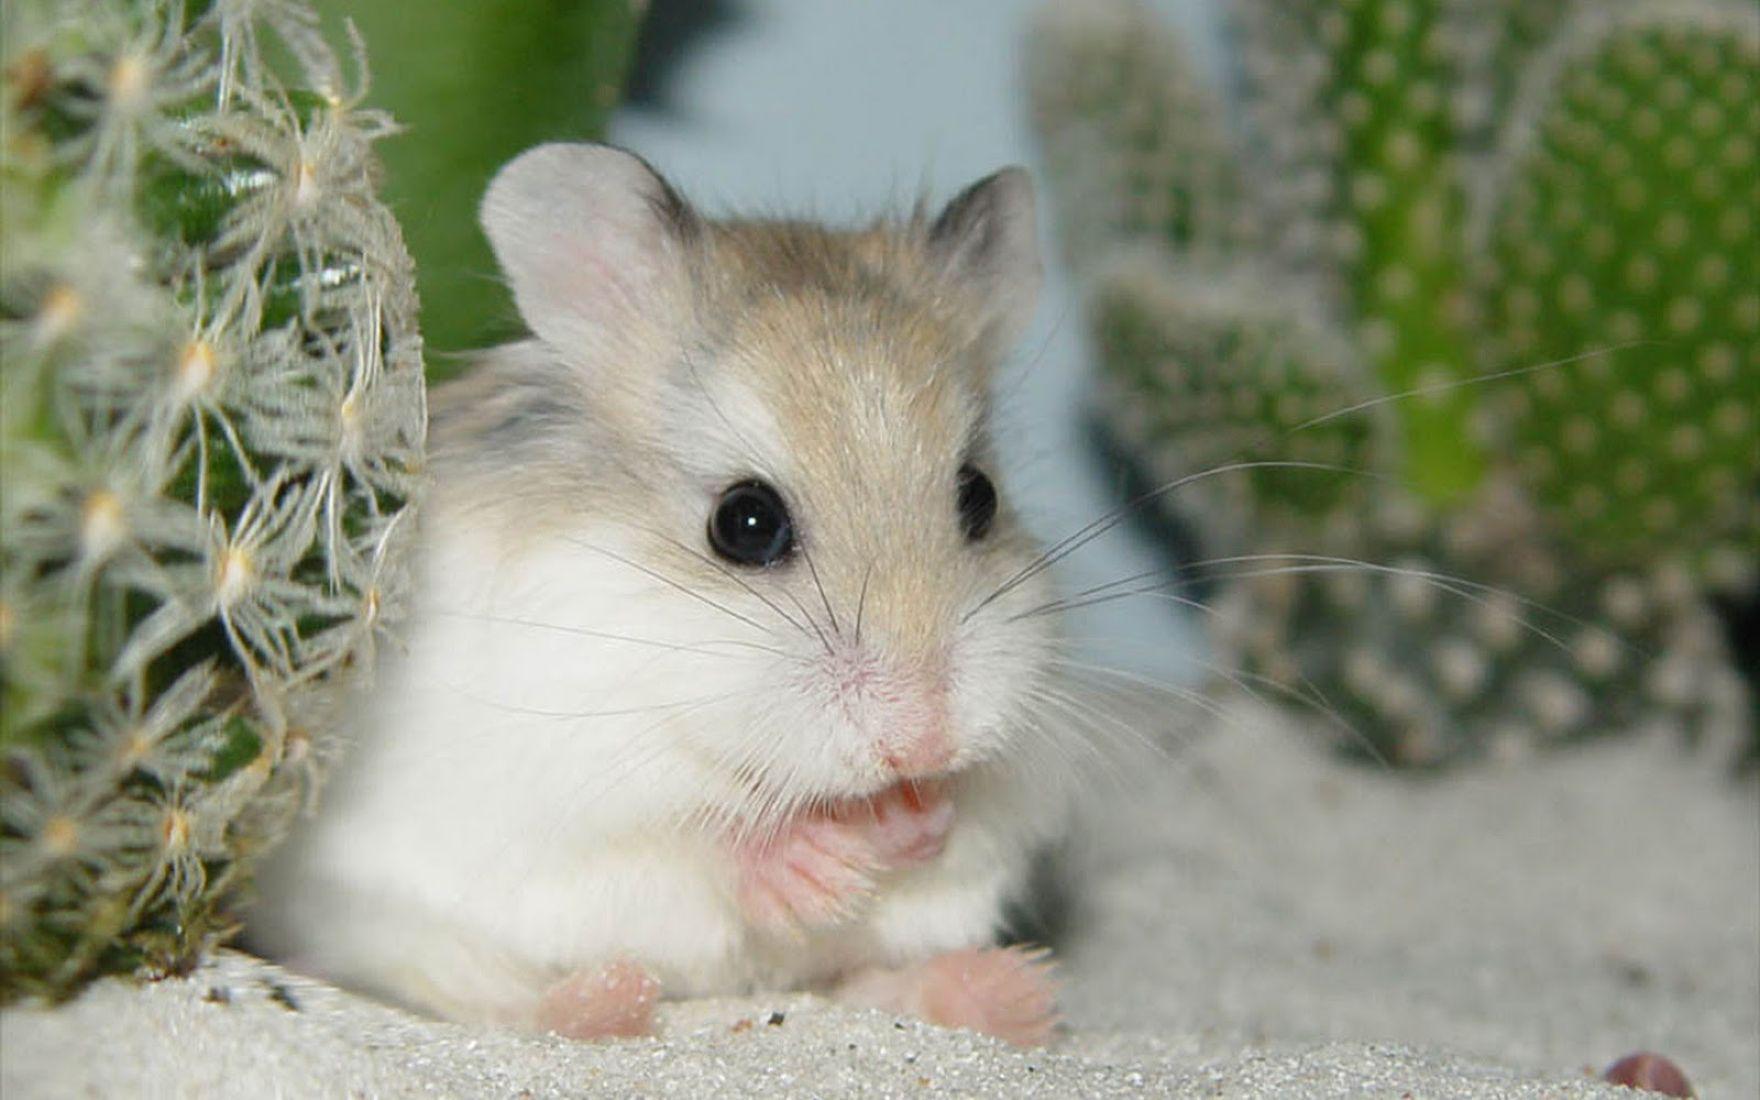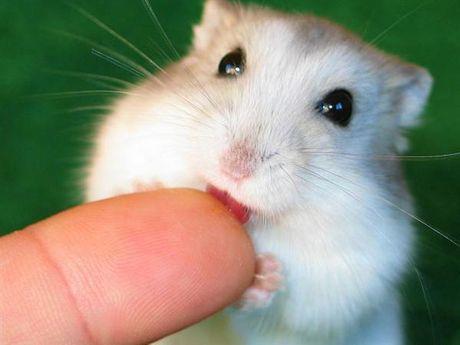The first image is the image on the left, the second image is the image on the right. For the images displayed, is the sentence "The rodent-type pet in the right image is on a green backdrop." factually correct? Answer yes or no. Yes. 